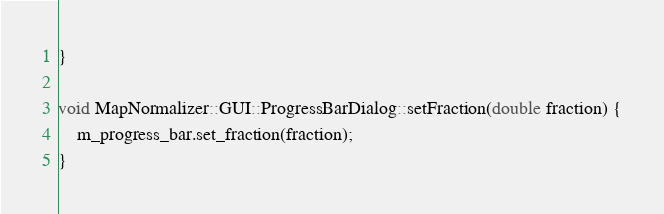Convert code to text. <code><loc_0><loc_0><loc_500><loc_500><_C++_>}

void MapNormalizer::GUI::ProgressBarDialog::setFraction(double fraction) {
    m_progress_bar.set_fraction(fraction);
}

</code> 